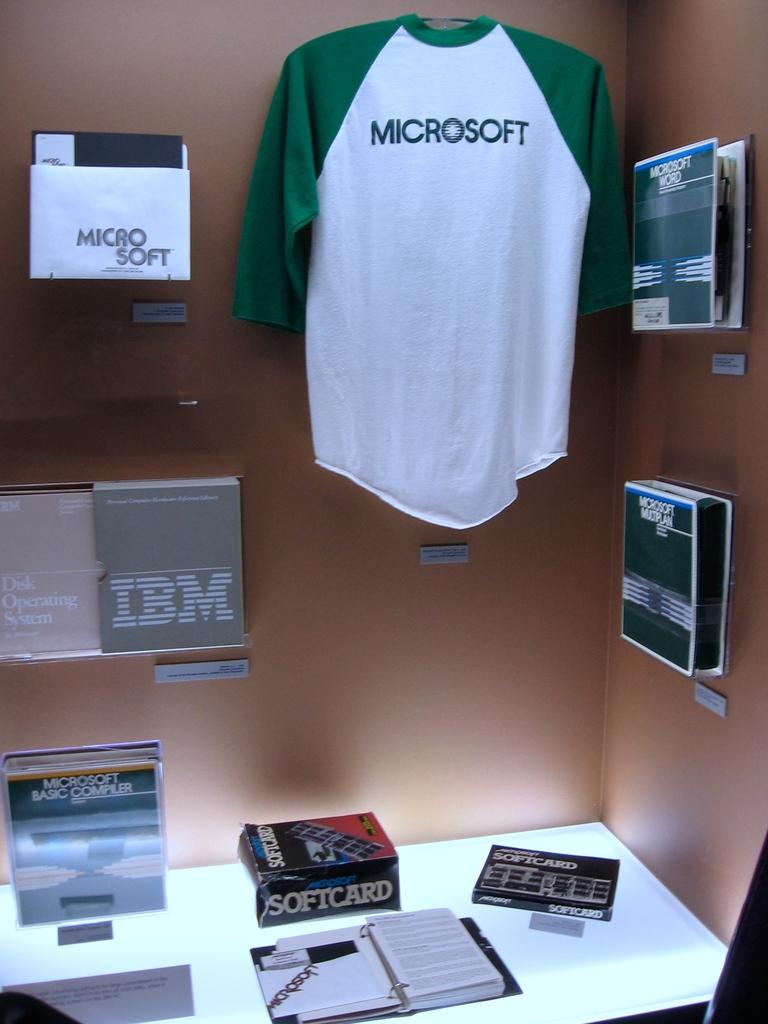<image>
Describe the image concisely. computer souvenirs adorn both a wall and desk like a microsoft baseball tee, IBM packaing and softcard 